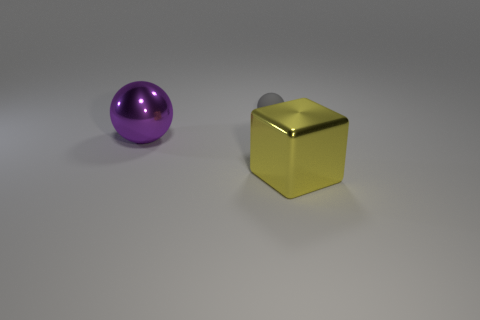Add 2 tiny yellow balls. How many objects exist? 5 Subtract all balls. How many objects are left? 1 Add 2 yellow metallic things. How many yellow metallic things are left? 3 Add 3 tiny gray matte spheres. How many tiny gray matte spheres exist? 4 Subtract 0 yellow spheres. How many objects are left? 3 Subtract all big purple balls. Subtract all gray balls. How many objects are left? 1 